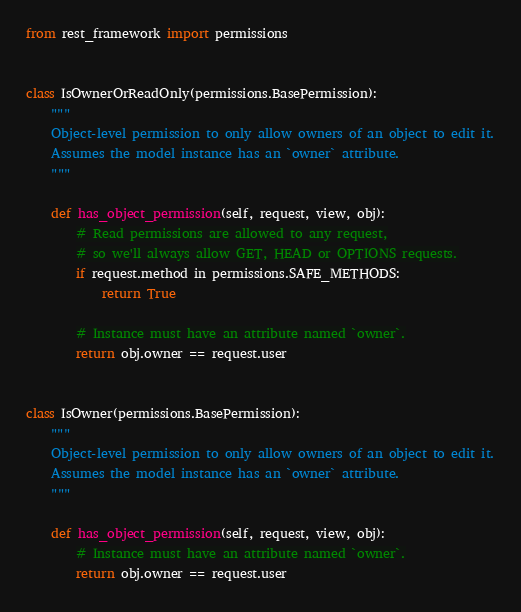<code> <loc_0><loc_0><loc_500><loc_500><_Python_>from rest_framework import permissions


class IsOwnerOrReadOnly(permissions.BasePermission):
    """
    Object-level permission to only allow owners of an object to edit it.
    Assumes the model instance has an `owner` attribute.
    """

    def has_object_permission(self, request, view, obj):
        # Read permissions are allowed to any request,
        # so we'll always allow GET, HEAD or OPTIONS requests.
        if request.method in permissions.SAFE_METHODS:
            return True

        # Instance must have an attribute named `owner`.
        return obj.owner == request.user
        
        
class IsOwner(permissions.BasePermission):
    """
    Object-level permission to only allow owners of an object to edit it.
    Assumes the model instance has an `owner` attribute.
    """

    def has_object_permission(self, request, view, obj):
        # Instance must have an attribute named `owner`.
        return obj.owner == request.user</code> 